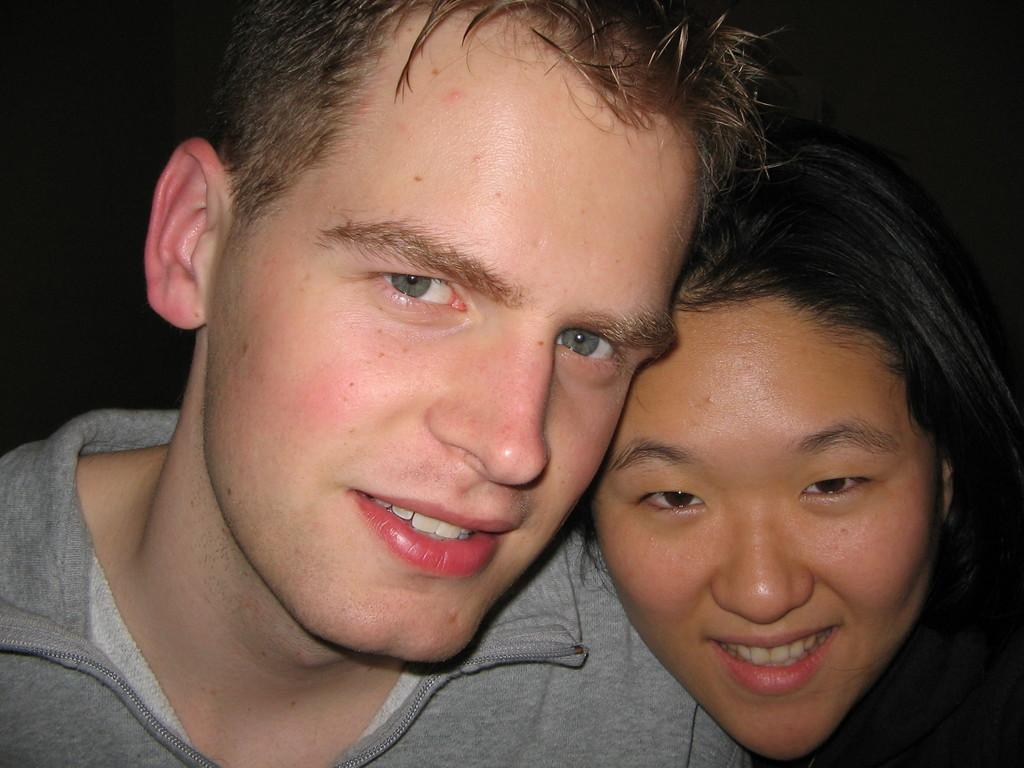Who are the people in the image? There is a man and a woman in the image. Where are the man and woman located in the image? The man and woman are in the middle of the image. What can be observed about the background of the image? The background of the image is dark. What type of shop can be seen in the background of the image? There is no shop visible in the image; the background is dark. 